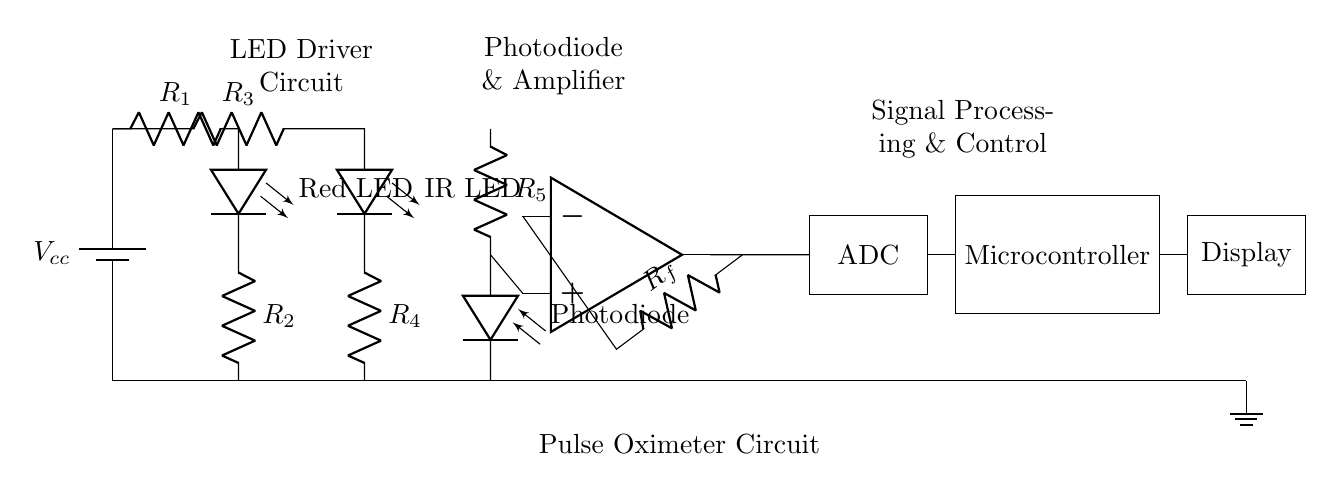What is the function of the LED circuit? The LED circuit consists of a red LED and an infrared LED, which emit light to measure blood oxygen levels based on the absorption characteristics of oxygenated and deoxygenated hemoglobin.
Answer: Emitting light What component processes the signal after the photodiode? The signal from the photodiode is processed by an operational amplifier, which amplifies the current signal generated by the light received from the LED reflections.
Answer: Operational amplifier How many resistors are in the circuit? The circuit contains five resistors, each serving to limit current to the LEDs and to set gain for the amplifier and photodiode.
Answer: Five What type of device is this circuit designed for? This circuit is specifically designed for use in a pulse oximeter, which is used to measure blood oxygen levels.
Answer: Pulse oximeter What does the ADC stand for in this circuit? The ADC stands for Analog to Digital Converter, which converts the analog voltage signals from the amplifier into digital data for further processing by the microcontroller.
Answer: Analog to Digital Converter How is the display connected in the circuit? The display is connected to the microcontroller, which sends the processed digital data from the ADC to display the blood oxygen levels to the user.
Answer: Through the microcontroller 